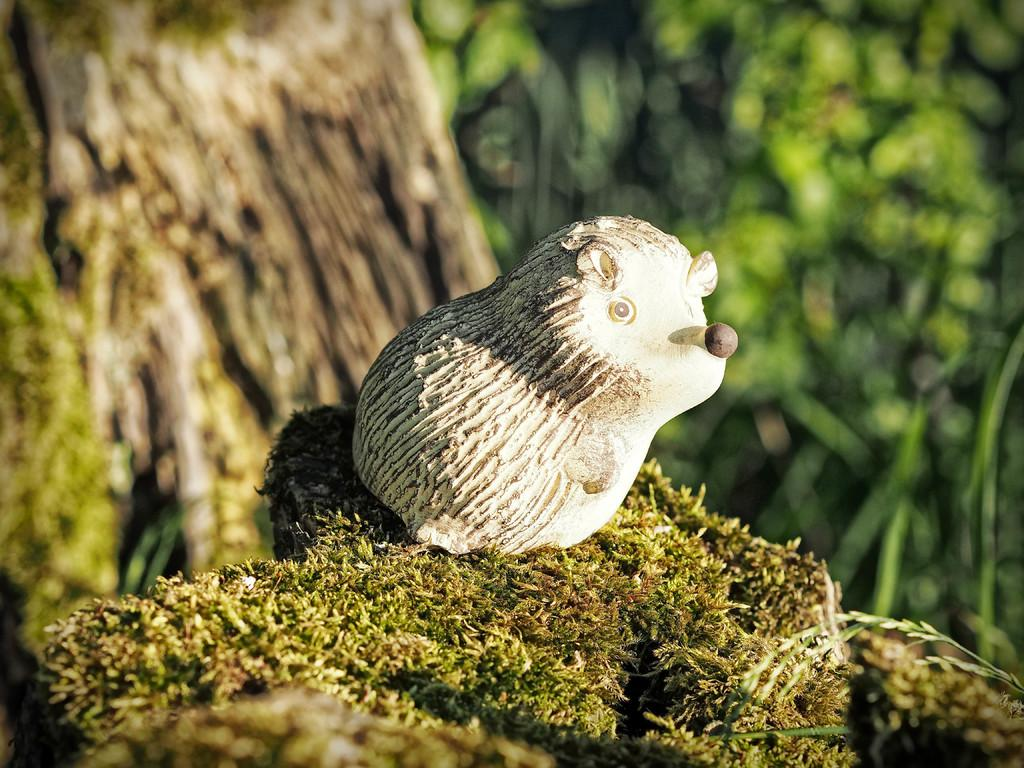What is located on the grass in the image? There is a toy on the grass. What can be seen in the distance in the image? There are trees in the background of the image. How would you describe the appearance of the background in the image? The background of the image is blurred. What type of learning material is visible in the image? There is no learning material present in the image; it features a toy on the grass and trees in the background. What sign or guide can be seen in the image? There is no sign or guide present in the image. 